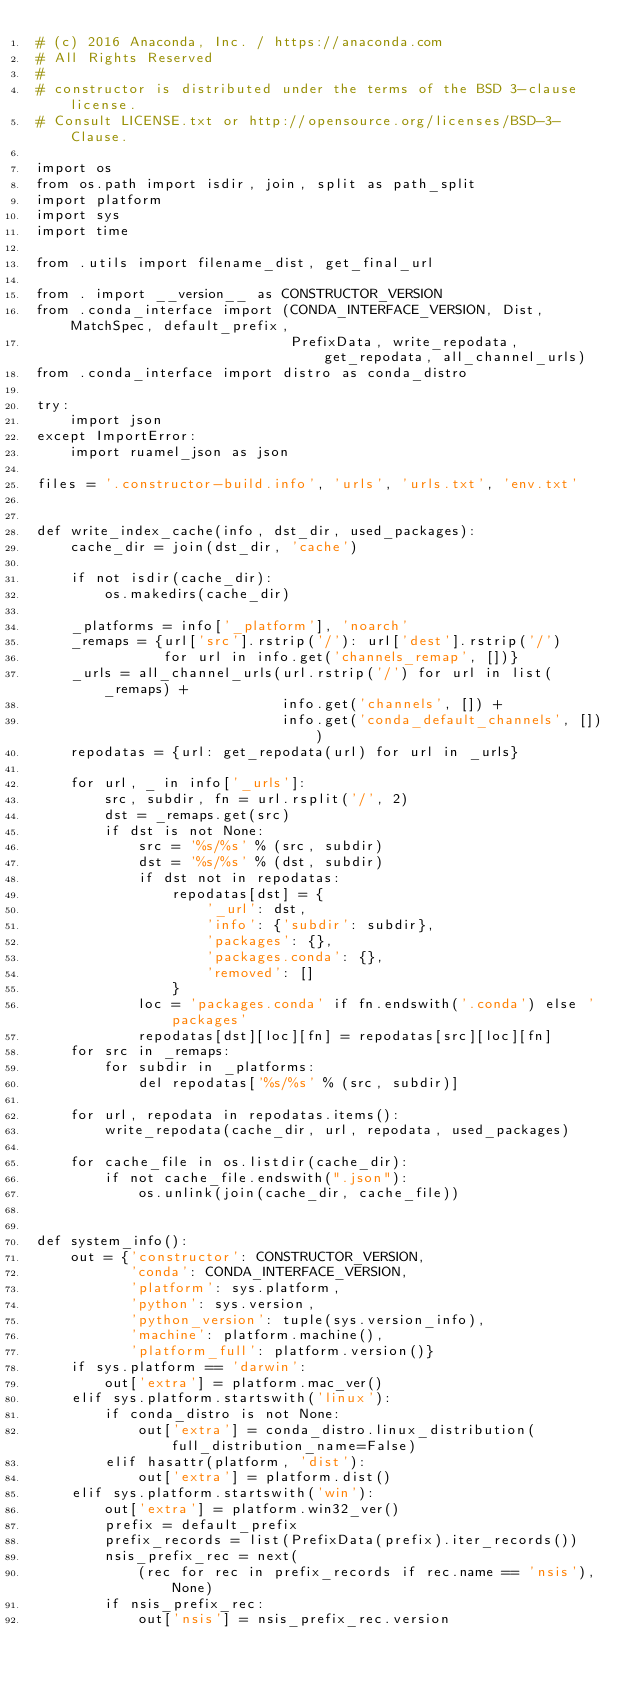<code> <loc_0><loc_0><loc_500><loc_500><_Python_># (c) 2016 Anaconda, Inc. / https://anaconda.com
# All Rights Reserved
#
# constructor is distributed under the terms of the BSD 3-clause license.
# Consult LICENSE.txt or http://opensource.org/licenses/BSD-3-Clause.

import os
from os.path import isdir, join, split as path_split
import platform
import sys
import time

from .utils import filename_dist, get_final_url

from . import __version__ as CONSTRUCTOR_VERSION
from .conda_interface import (CONDA_INTERFACE_VERSION, Dist, MatchSpec, default_prefix,
                              PrefixData, write_repodata, get_repodata, all_channel_urls)
from .conda_interface import distro as conda_distro

try:
    import json
except ImportError:
    import ruamel_json as json

files = '.constructor-build.info', 'urls', 'urls.txt', 'env.txt'


def write_index_cache(info, dst_dir, used_packages):
    cache_dir = join(dst_dir, 'cache')

    if not isdir(cache_dir):
        os.makedirs(cache_dir)

    _platforms = info['_platform'], 'noarch'
    _remaps = {url['src'].rstrip('/'): url['dest'].rstrip('/')
               for url in info.get('channels_remap', [])}
    _urls = all_channel_urls(url.rstrip('/') for url in list(_remaps) +
                             info.get('channels', []) +
                             info.get('conda_default_channels', []))
    repodatas = {url: get_repodata(url) for url in _urls}

    for url, _ in info['_urls']:
        src, subdir, fn = url.rsplit('/', 2)
        dst = _remaps.get(src)
        if dst is not None:
            src = '%s/%s' % (src, subdir)
            dst = '%s/%s' % (dst, subdir)
            if dst not in repodatas:
                repodatas[dst] = {
                    '_url': dst,
                    'info': {'subdir': subdir},
                    'packages': {},
                    'packages.conda': {},
                    'removed': []
                }
            loc = 'packages.conda' if fn.endswith('.conda') else 'packages'
            repodatas[dst][loc][fn] = repodatas[src][loc][fn]
    for src in _remaps:
        for subdir in _platforms:
            del repodatas['%s/%s' % (src, subdir)]

    for url, repodata in repodatas.items():
        write_repodata(cache_dir, url, repodata, used_packages)

    for cache_file in os.listdir(cache_dir):
        if not cache_file.endswith(".json"):
            os.unlink(join(cache_dir, cache_file))


def system_info():
    out = {'constructor': CONSTRUCTOR_VERSION,
           'conda': CONDA_INTERFACE_VERSION,
           'platform': sys.platform,
           'python': sys.version,
           'python_version': tuple(sys.version_info),
           'machine': platform.machine(),
           'platform_full': platform.version()}
    if sys.platform == 'darwin':
        out['extra'] = platform.mac_ver()
    elif sys.platform.startswith('linux'):
        if conda_distro is not None:
            out['extra'] = conda_distro.linux_distribution(full_distribution_name=False)
        elif hasattr(platform, 'dist'):
            out['extra'] = platform.dist()
    elif sys.platform.startswith('win'):
        out['extra'] = platform.win32_ver()
        prefix = default_prefix
        prefix_records = list(PrefixData(prefix).iter_records())
        nsis_prefix_rec = next(
            (rec for rec in prefix_records if rec.name == 'nsis'), None)
        if nsis_prefix_rec:
            out['nsis'] = nsis_prefix_rec.version</code> 